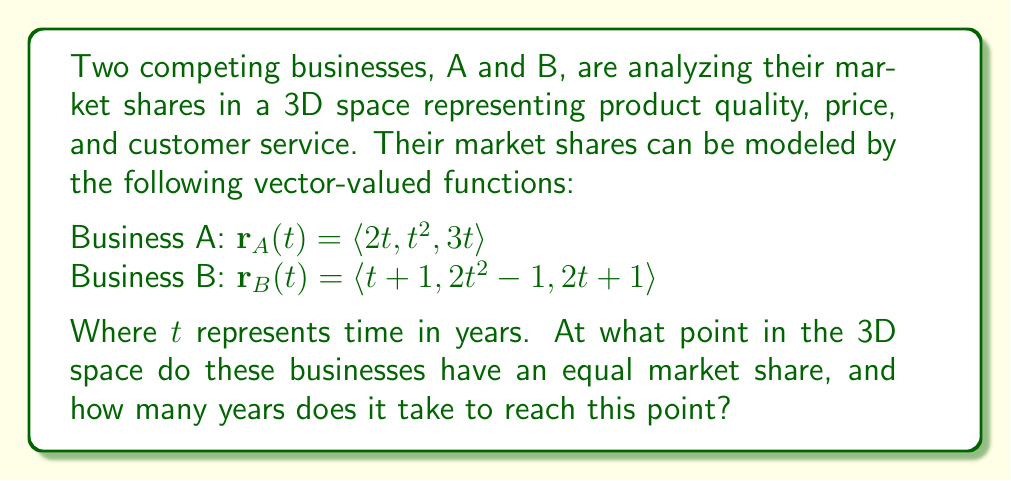Could you help me with this problem? To find the intersection of the two market share functions, we need to set the components of $\mathbf{r}_A(t)$ and $\mathbf{r}_B(t)$ equal to each other:

1) For the x-component (product quality):
   $2t = t+1$
   $t = 1$

2) For the y-component (price):
   $t^2 = 2t^2-1$
   $-t^2 = -1$
   $t^2 = 1$
   $t = \pm 1$ (we'll use $t = 1$ to match the x-component)

3) For the z-component (customer service):
   $3t = 2t+1$
   $t = 1$

We can see that $t = 1$ satisfies all three equations, confirming the intersection point.

To find the coordinates of the intersection point, we substitute $t = 1$ into either $\mathbf{r}_A(t)$ or $\mathbf{r}_B(t)$:

$\mathbf{r}_A(1) = \langle 2(1), 1^2, 3(1) \rangle = \langle 2, 1, 3 \rangle$

Therefore, the businesses have an equal market share at the point (2, 1, 3) in the 3D space representing product quality, price, and customer service.

The time it takes to reach this point is 1 year, as $t = 1$.
Answer: The businesses have an equal market share at the point (2, 1, 3) in the 3D space, and it takes 1 year to reach this point. 